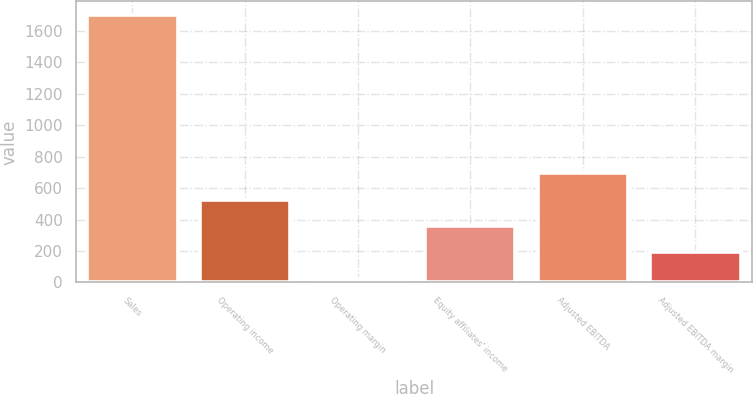Convert chart to OTSL. <chart><loc_0><loc_0><loc_500><loc_500><bar_chart><fcel>Sales<fcel>Operating income<fcel>Operating margin<fcel>Equity affiliates' income<fcel>Adjusted EBITDA<fcel>Adjusted EBITDA margin<nl><fcel>1704.4<fcel>527.14<fcel>22.6<fcel>358.96<fcel>695.32<fcel>190.78<nl></chart> 